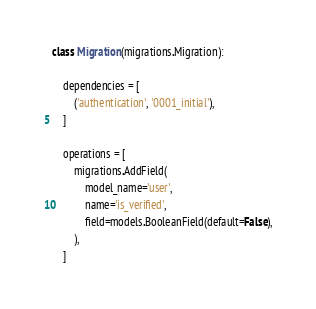<code> <loc_0><loc_0><loc_500><loc_500><_Python_>

class Migration(migrations.Migration):

    dependencies = [
        ('authentication', '0001_initial'),
    ]

    operations = [
        migrations.AddField(
            model_name='user',
            name='is_verified',
            field=models.BooleanField(default=False),
        ),
    ]
</code> 